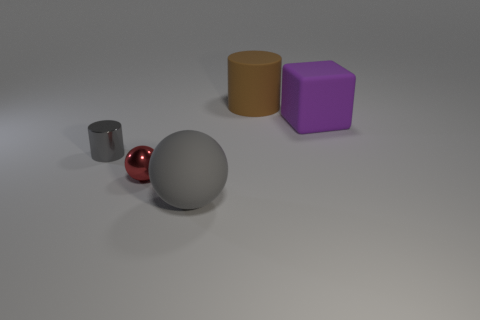How many rubber objects are behind the matte object that is in front of the shiny ball?
Offer a very short reply. 2. What number of tiny gray things have the same shape as the tiny red metal thing?
Provide a succinct answer. 0. What number of small things are there?
Give a very brief answer. 2. What is the color of the ball that is on the left side of the gray matte ball?
Ensure brevity in your answer.  Red. What color is the matte thing that is in front of the large matte object that is on the right side of the big cylinder?
Provide a short and direct response. Gray. What is the color of the cube that is the same size as the gray sphere?
Offer a terse response. Purple. What number of objects are in front of the brown matte thing and behind the purple matte object?
Your response must be concise. 0. The big thing that is the same color as the metallic cylinder is what shape?
Make the answer very short. Sphere. What is the material of the thing that is on the left side of the big gray matte sphere and in front of the gray cylinder?
Make the answer very short. Metal. Is the number of red shiny balls that are in front of the large gray rubber sphere less than the number of objects that are right of the small gray object?
Offer a very short reply. Yes. 